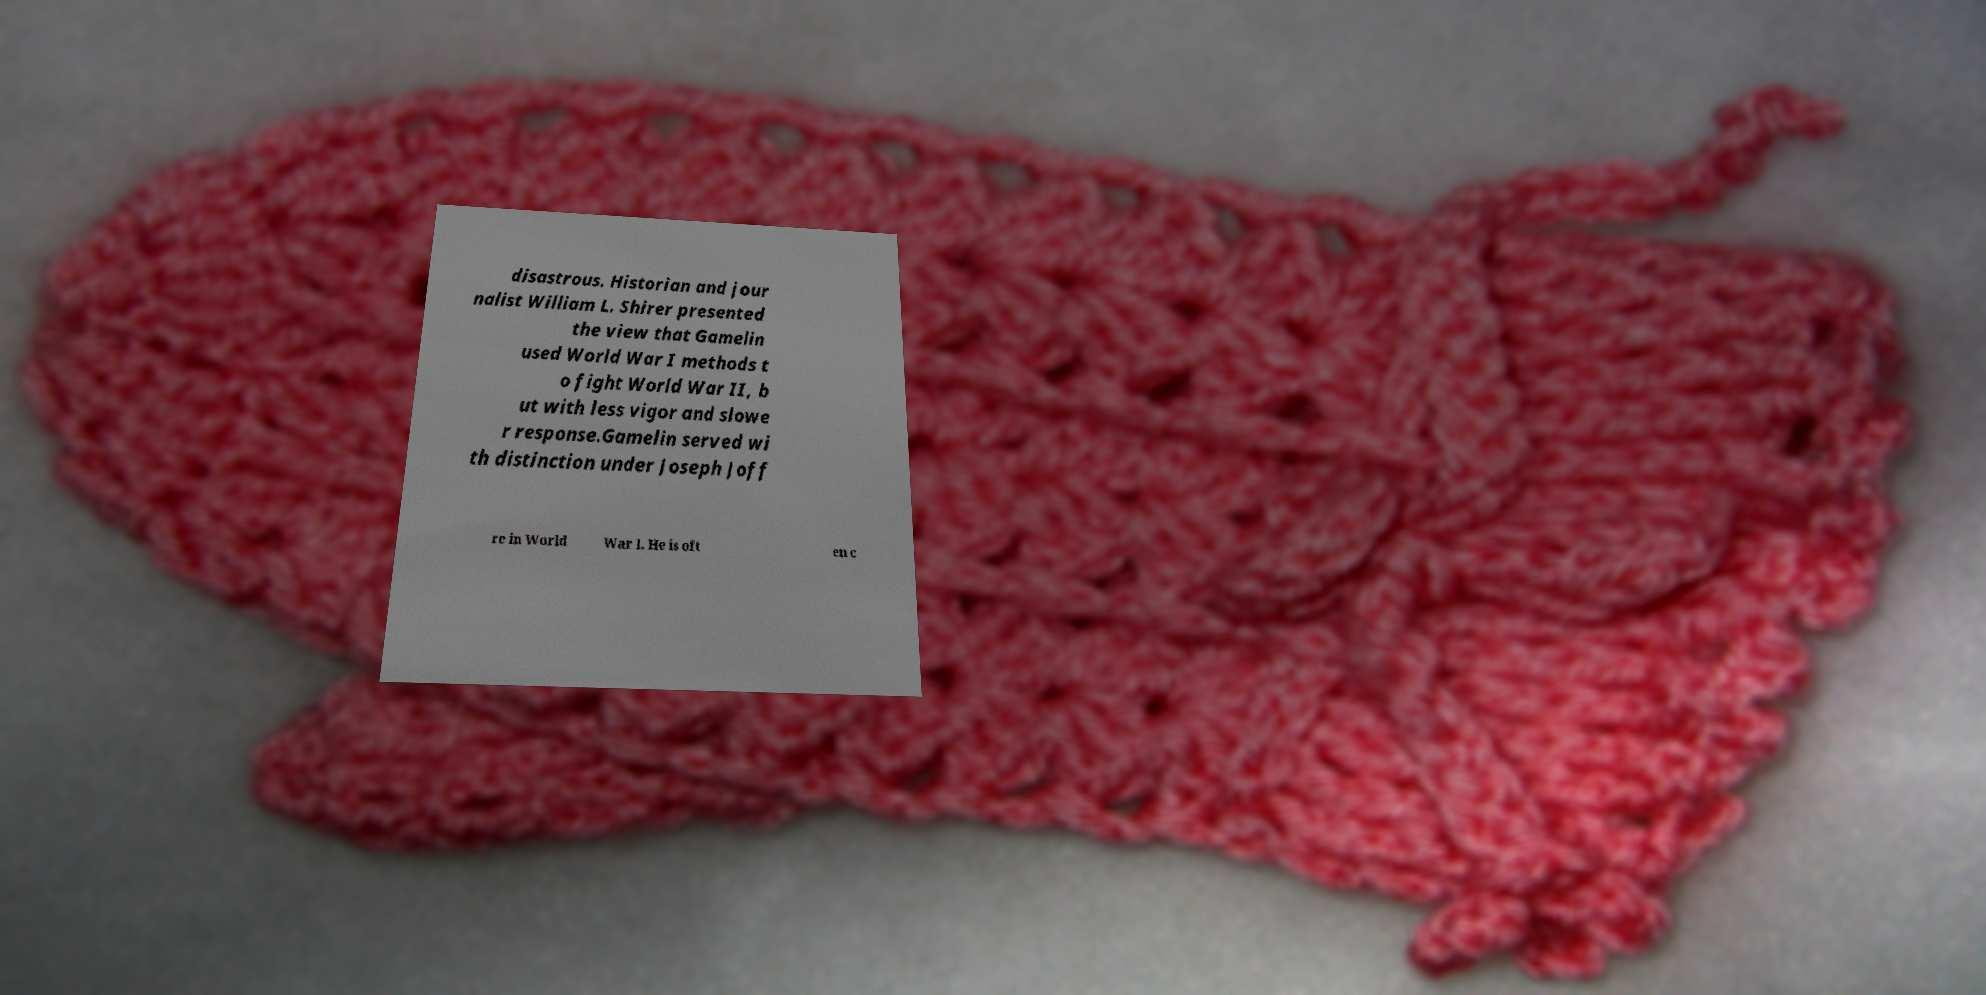Could you assist in decoding the text presented in this image and type it out clearly? disastrous. Historian and jour nalist William L. Shirer presented the view that Gamelin used World War I methods t o fight World War II, b ut with less vigor and slowe r response.Gamelin served wi th distinction under Joseph Joff re in World War I. He is oft en c 